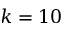Convert formula to latex. <formula><loc_0><loc_0><loc_500><loc_500>k = 1 0</formula> 